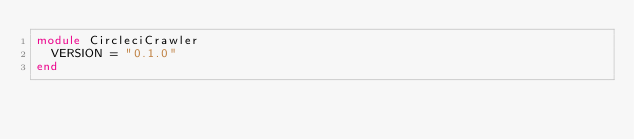Convert code to text. <code><loc_0><loc_0><loc_500><loc_500><_Ruby_>module CircleciCrawler
  VERSION = "0.1.0"
end
</code> 